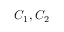<formula> <loc_0><loc_0><loc_500><loc_500>C _ { 1 } , C _ { 2 }</formula> 